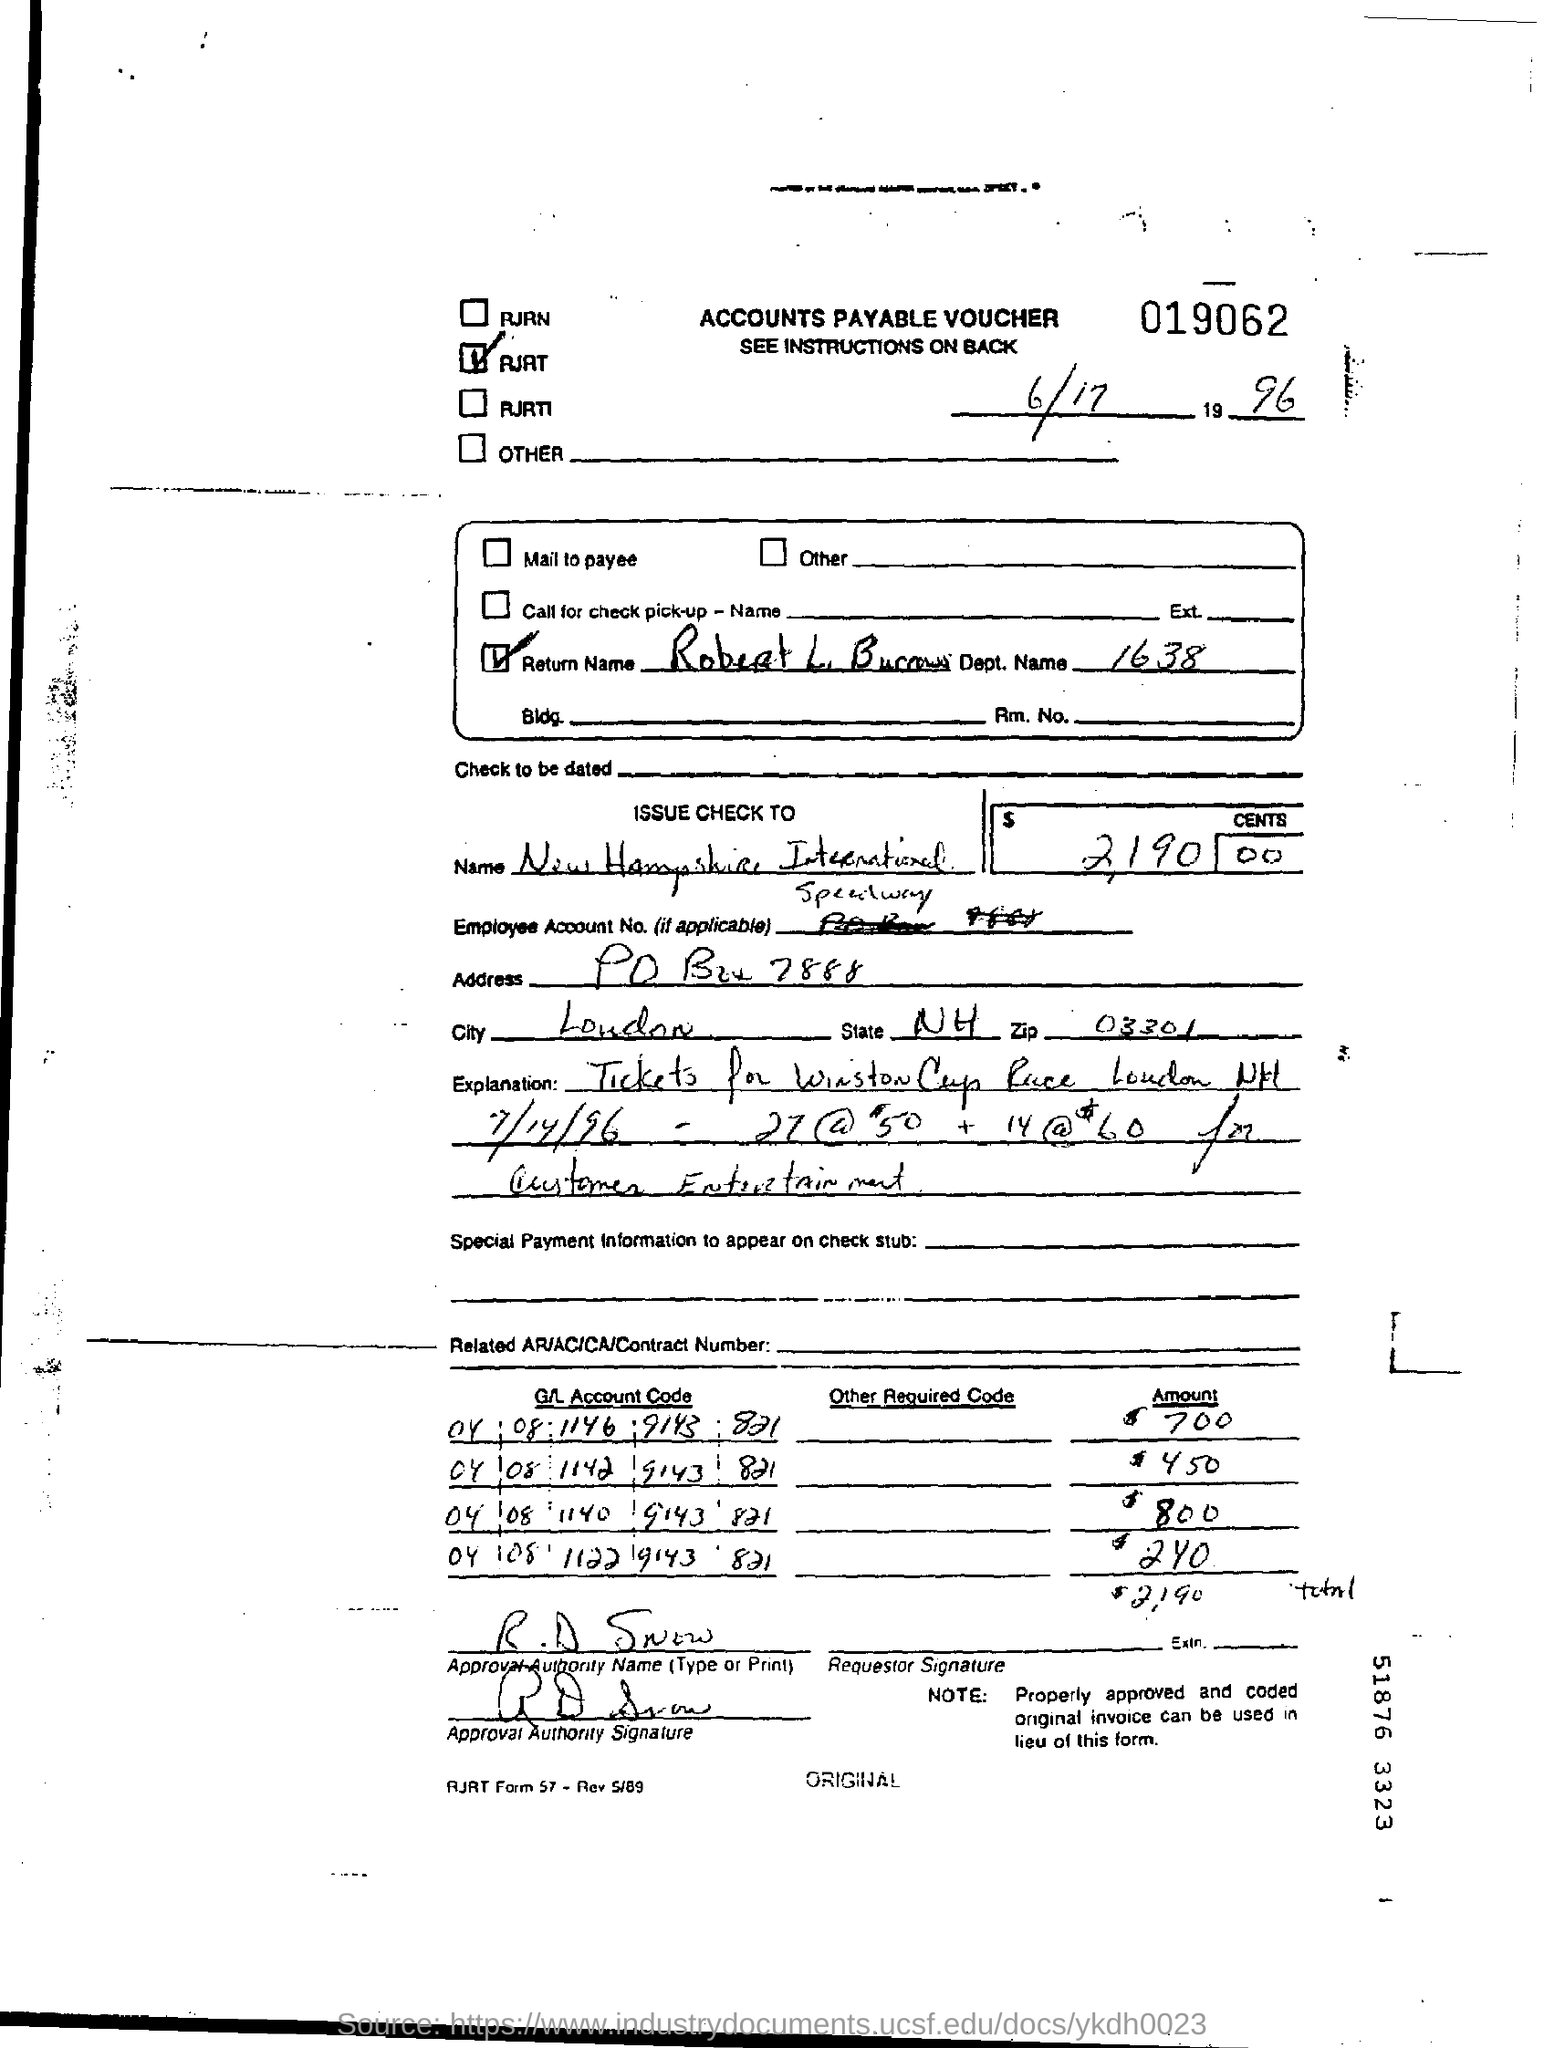Indicate a few pertinent items in this graphic. The approval authority for the voucher is R.D. Snow. The zip code is 03301, and it is included in the given address. The check is issued in the name of New Hampshire International. 